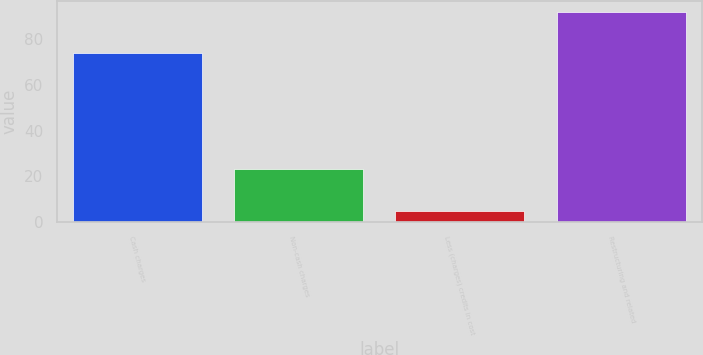Convert chart. <chart><loc_0><loc_0><loc_500><loc_500><bar_chart><fcel>Cash charges<fcel>Non-cash charges<fcel>Less (charges) credits in cost<fcel>Restructuring and related<nl><fcel>74<fcel>23<fcel>5<fcel>92<nl></chart> 